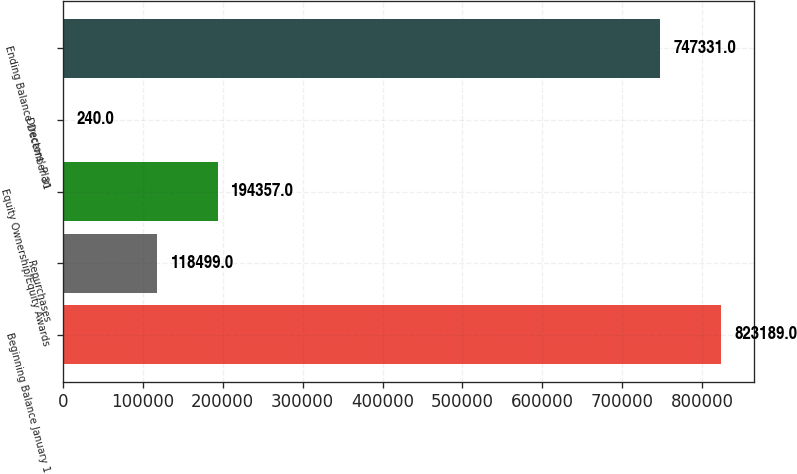Convert chart. <chart><loc_0><loc_0><loc_500><loc_500><bar_chart><fcel>Beginning Balance January 1<fcel>Repurchases<fcel>Equity Ownership/Equity Awards<fcel>Directors' Plan<fcel>Ending Balance December 31<nl><fcel>823189<fcel>118499<fcel>194357<fcel>240<fcel>747331<nl></chart> 